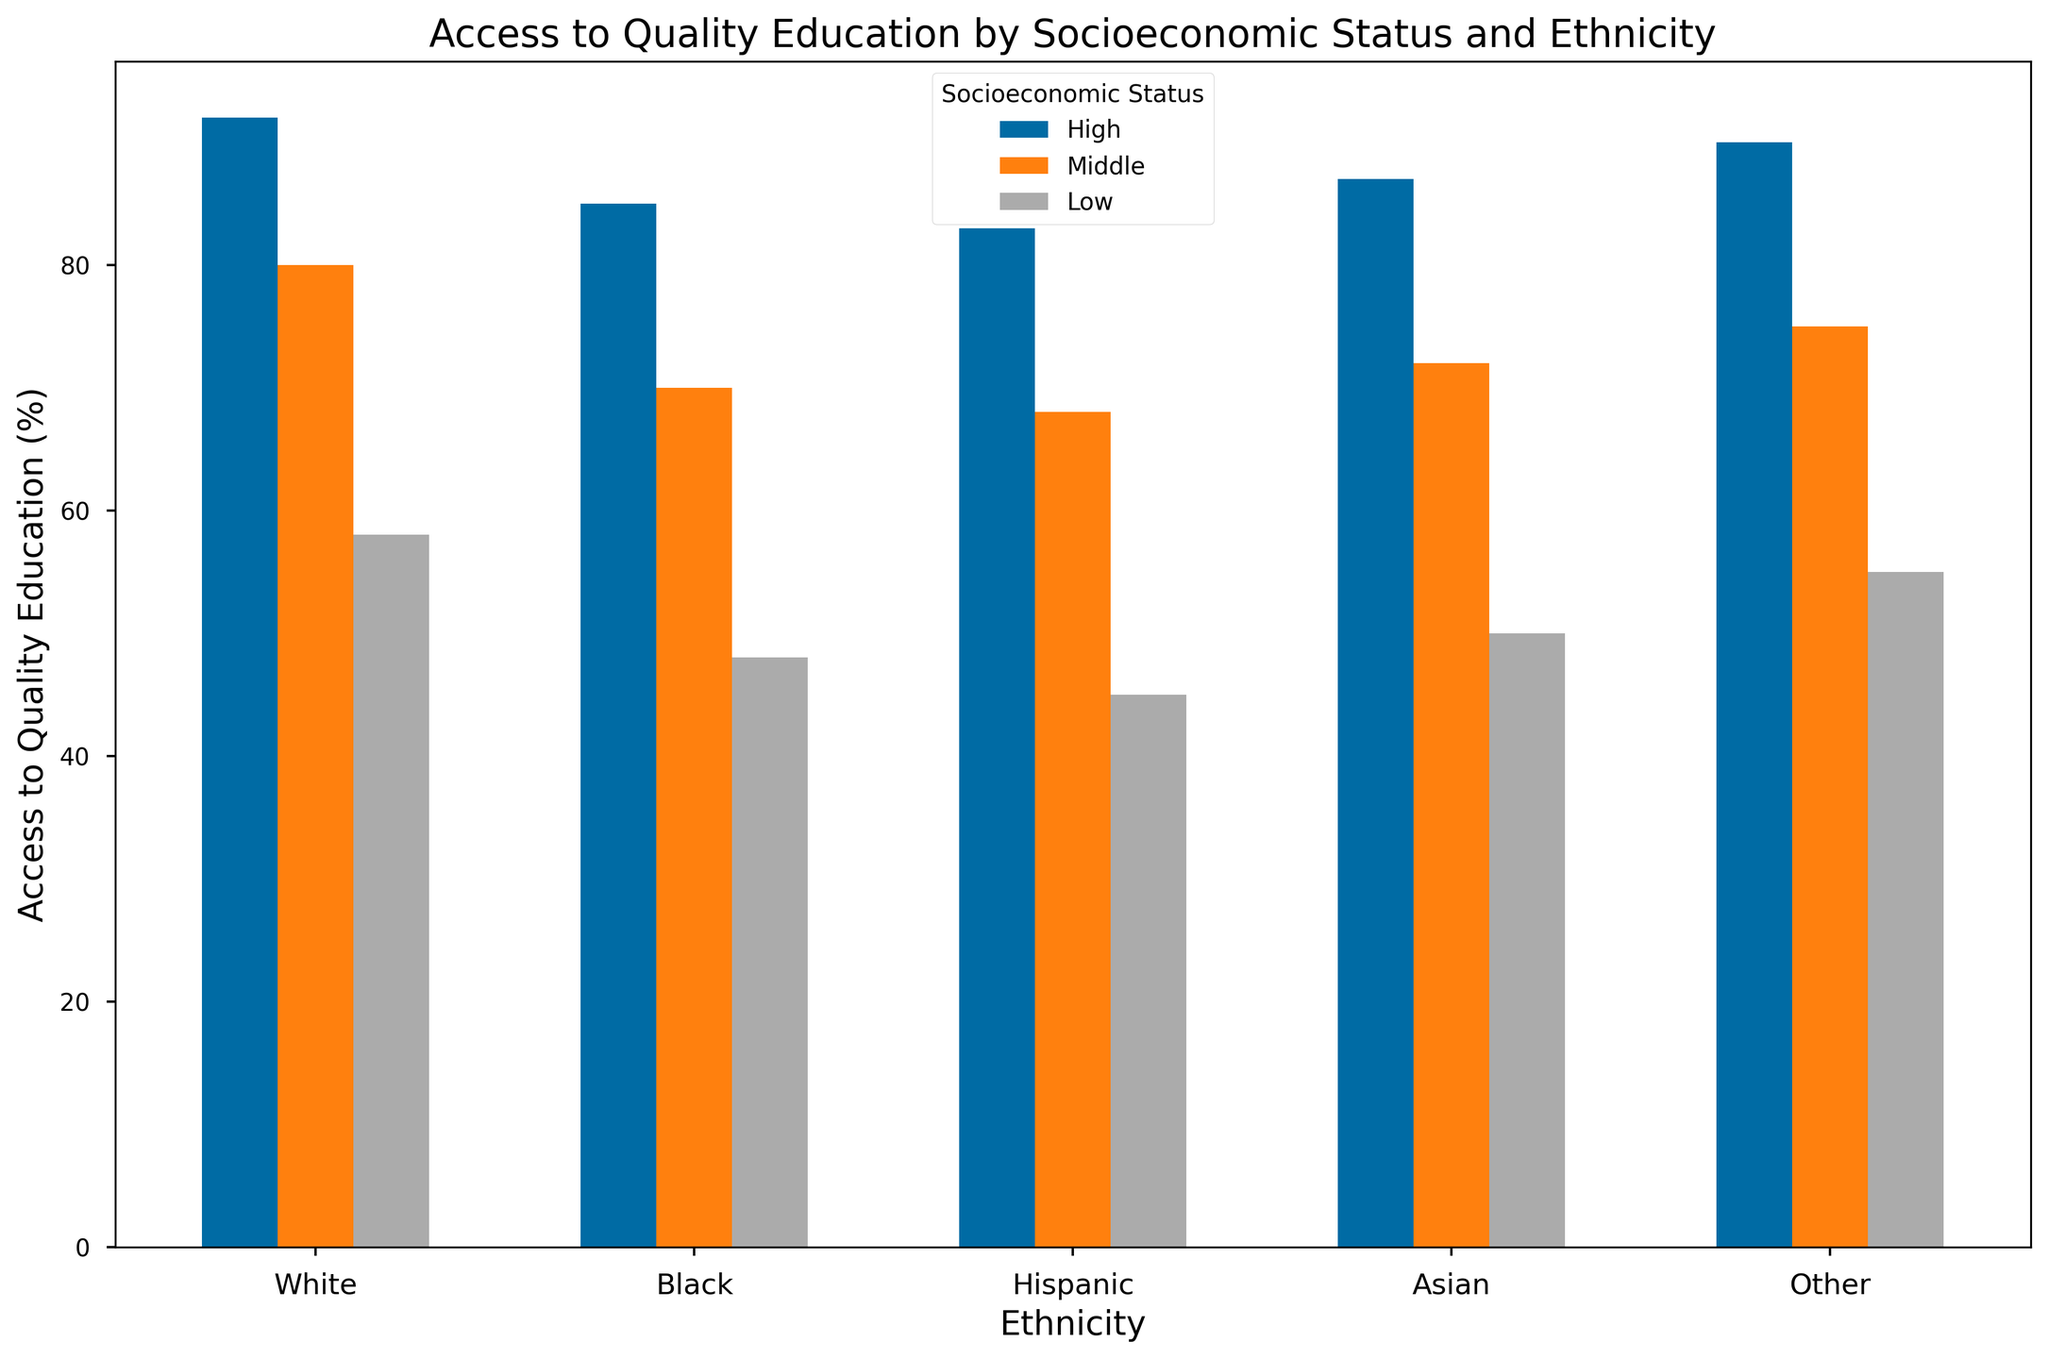What's the highest percentage of access to quality education among all ethnicities and socioeconomic statuses? The highest bar represents the highest percentage. The "High" socioeconomic status for Asians shows the tallest bar with 92%, indicating the highest access to quality education among all categories.
Answer: 92 How does the access to quality education for Hispanic students in the middle socioeconomic group compare to Black students in the same group? For middle socioeconomic status, the bar for Hispanic students shows 68%, and the bar for Black students shows 70%. So, Black students in the middle socioeconomic group have slightly higher access to quality education.
Answer: Black students have higher access What is the difference in access to quality education between the highest and the lowest socioeconomic statuses for White students? For White students, the highest socioeconomic status shows 90% access while the lowest shows 55% access. The difference is calculated as 90 - 55.
Answer: 35 Among all ethnicities, which socioeconomic status group shows the least access to quality education, and what is the percentage? The least access to quality education is shown by the lowest bar across all categories. The "Low" socioeconomic status for Hispanic students has the shortest bar with 45%.
Answer: Low, 45 What's the combined average access to quality education for all ethnicities in the middle socioeconomic group? Sum all values in the middle socioeconomic group: 75 + 70 + 68 + 80 + 72 = 365. The number of values is 5. The average is calculated as 365 / 5.
Answer: 73 Does the "Other" ethnicity have greater access to quality education in the middle or low socioeconomic status? For the "Other" ethnicity, middle socioeconomic status has a bar at 72%, while low socioeconomic status has a bar at 50%. Thus, middle socioeconomic status has greater access.
Answer: Middle What is the relative difference in access to quality education between Black students in high and low socioeconomic statuses? The access for Black students in high socioeconomic status is 85%, and in low socioeconomic status, it is 48%. Relative difference is calculated as (85 - 48) / 48 x 100%.
Answer: 77.08% Which ethnic group shows the largest drop in access to quality education from high to low socioeconomic status? Calculate the drop for each ethnicity: White (90-55)=35, Black (85-48)=37, Hispanic (83-45)=38, Asian (92-58)=34, Other (87-50)=37. Hispanic shows the largest drop with 38 percentage points.
Answer: Hispanic What is the average access to quality education for Asian students, considering all socioeconomic statuses? Sum the access percentages for Asian students: 92 + 80 + 58 = 230. There are 3 socioeconomic statuses. The average is calculated as 230 / 3.
Answer: 76.67 